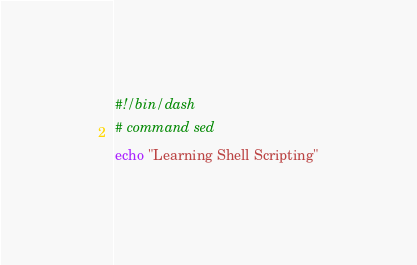<code> <loc_0><loc_0><loc_500><loc_500><_Bash_>#!/bin/dash
# command sed
echo "Learning Shell Scripting"</code> 